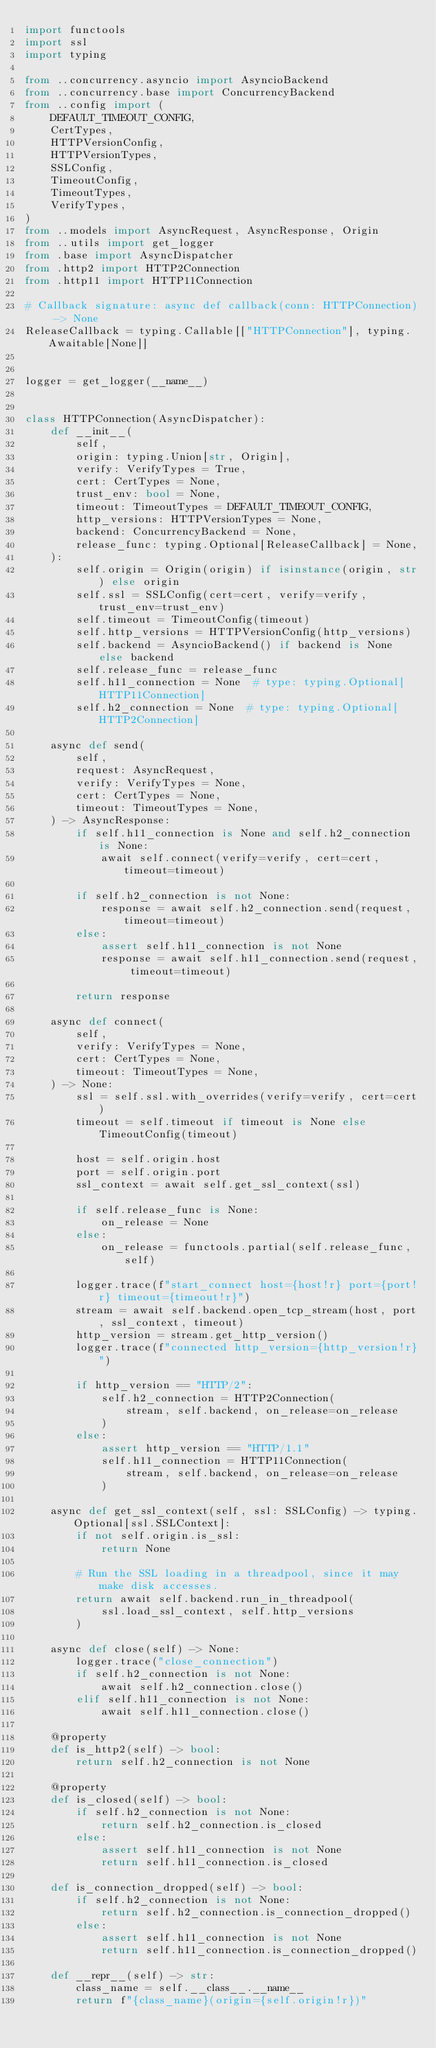<code> <loc_0><loc_0><loc_500><loc_500><_Python_>import functools
import ssl
import typing

from ..concurrency.asyncio import AsyncioBackend
from ..concurrency.base import ConcurrencyBackend
from ..config import (
    DEFAULT_TIMEOUT_CONFIG,
    CertTypes,
    HTTPVersionConfig,
    HTTPVersionTypes,
    SSLConfig,
    TimeoutConfig,
    TimeoutTypes,
    VerifyTypes,
)
from ..models import AsyncRequest, AsyncResponse, Origin
from ..utils import get_logger
from .base import AsyncDispatcher
from .http2 import HTTP2Connection
from .http11 import HTTP11Connection

# Callback signature: async def callback(conn: HTTPConnection) -> None
ReleaseCallback = typing.Callable[["HTTPConnection"], typing.Awaitable[None]]


logger = get_logger(__name__)


class HTTPConnection(AsyncDispatcher):
    def __init__(
        self,
        origin: typing.Union[str, Origin],
        verify: VerifyTypes = True,
        cert: CertTypes = None,
        trust_env: bool = None,
        timeout: TimeoutTypes = DEFAULT_TIMEOUT_CONFIG,
        http_versions: HTTPVersionTypes = None,
        backend: ConcurrencyBackend = None,
        release_func: typing.Optional[ReleaseCallback] = None,
    ):
        self.origin = Origin(origin) if isinstance(origin, str) else origin
        self.ssl = SSLConfig(cert=cert, verify=verify, trust_env=trust_env)
        self.timeout = TimeoutConfig(timeout)
        self.http_versions = HTTPVersionConfig(http_versions)
        self.backend = AsyncioBackend() if backend is None else backend
        self.release_func = release_func
        self.h11_connection = None  # type: typing.Optional[HTTP11Connection]
        self.h2_connection = None  # type: typing.Optional[HTTP2Connection]

    async def send(
        self,
        request: AsyncRequest,
        verify: VerifyTypes = None,
        cert: CertTypes = None,
        timeout: TimeoutTypes = None,
    ) -> AsyncResponse:
        if self.h11_connection is None and self.h2_connection is None:
            await self.connect(verify=verify, cert=cert, timeout=timeout)

        if self.h2_connection is not None:
            response = await self.h2_connection.send(request, timeout=timeout)
        else:
            assert self.h11_connection is not None
            response = await self.h11_connection.send(request, timeout=timeout)

        return response

    async def connect(
        self,
        verify: VerifyTypes = None,
        cert: CertTypes = None,
        timeout: TimeoutTypes = None,
    ) -> None:
        ssl = self.ssl.with_overrides(verify=verify, cert=cert)
        timeout = self.timeout if timeout is None else TimeoutConfig(timeout)

        host = self.origin.host
        port = self.origin.port
        ssl_context = await self.get_ssl_context(ssl)

        if self.release_func is None:
            on_release = None
        else:
            on_release = functools.partial(self.release_func, self)

        logger.trace(f"start_connect host={host!r} port={port!r} timeout={timeout!r}")
        stream = await self.backend.open_tcp_stream(host, port, ssl_context, timeout)
        http_version = stream.get_http_version()
        logger.trace(f"connected http_version={http_version!r}")

        if http_version == "HTTP/2":
            self.h2_connection = HTTP2Connection(
                stream, self.backend, on_release=on_release
            )
        else:
            assert http_version == "HTTP/1.1"
            self.h11_connection = HTTP11Connection(
                stream, self.backend, on_release=on_release
            )

    async def get_ssl_context(self, ssl: SSLConfig) -> typing.Optional[ssl.SSLContext]:
        if not self.origin.is_ssl:
            return None

        # Run the SSL loading in a threadpool, since it may make disk accesses.
        return await self.backend.run_in_threadpool(
            ssl.load_ssl_context, self.http_versions
        )

    async def close(self) -> None:
        logger.trace("close_connection")
        if self.h2_connection is not None:
            await self.h2_connection.close()
        elif self.h11_connection is not None:
            await self.h11_connection.close()

    @property
    def is_http2(self) -> bool:
        return self.h2_connection is not None

    @property
    def is_closed(self) -> bool:
        if self.h2_connection is not None:
            return self.h2_connection.is_closed
        else:
            assert self.h11_connection is not None
            return self.h11_connection.is_closed

    def is_connection_dropped(self) -> bool:
        if self.h2_connection is not None:
            return self.h2_connection.is_connection_dropped()
        else:
            assert self.h11_connection is not None
            return self.h11_connection.is_connection_dropped()

    def __repr__(self) -> str:
        class_name = self.__class__.__name__
        return f"{class_name}(origin={self.origin!r})"
</code> 